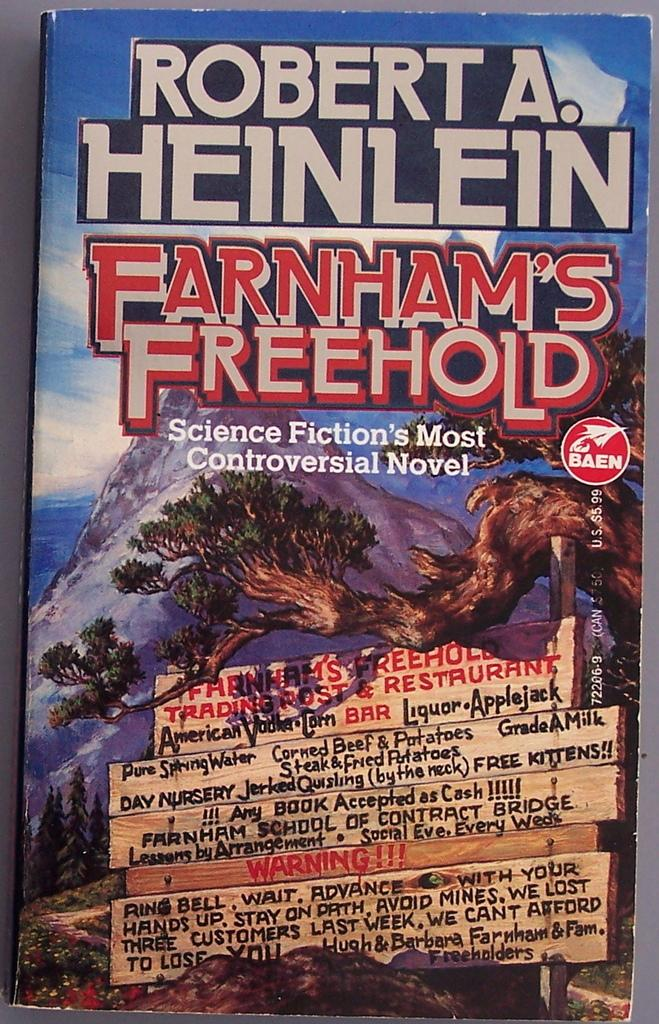<image>
Create a compact narrative representing the image presented. A Robert A. Heinlein novel with a mountain top and a tree on the cover. 